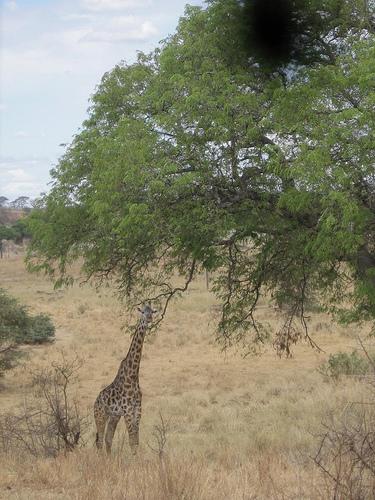What is the giraffe's neck parallel to?
Keep it brief. Tree. What color is this animal?
Keep it brief. Brown and white. Are the giraffes on alert?
Give a very brief answer. Yes. Are the giraffe's males or female?
Write a very short answer. Male. Are there two giraffes in this picture?
Write a very short answer. No. Has a tree fallen off?
Concise answer only. No. Is this giraffe in the wild?
Be succinct. Yes. Is that a baby elephant?
Be succinct. No. Is there water?
Concise answer only. No. How many giraffes?
Concise answer only. 1. Is there an elephant in the picture?
Give a very brief answer. No. Is this animal in the wild?
Give a very brief answer. Yes. How many giraffes are eating leaves?
Concise answer only. 1. How many different species of animals do you see?
Keep it brief. 1. How many animals do you see?
Give a very brief answer. 1. Is there a water source for the animals?
Concise answer only. No. Are the animals in water?
Be succinct. No. What animals are pictured?
Concise answer only. Giraffe. Is the giraffe resting?
Concise answer only. No. What is the animal eating?
Concise answer only. Leaves. Is the grass green?
Concise answer only. No. What color is the grass?
Quick response, please. Brown. Is the animal running?
Write a very short answer. No. Are they in the wild?
Write a very short answer. Yes. Does the giraffe in this picture only eat leaves?
Keep it brief. Yes. Is there a bench?
Be succinct. No. Is there a body of water nearby?
Write a very short answer. No. 